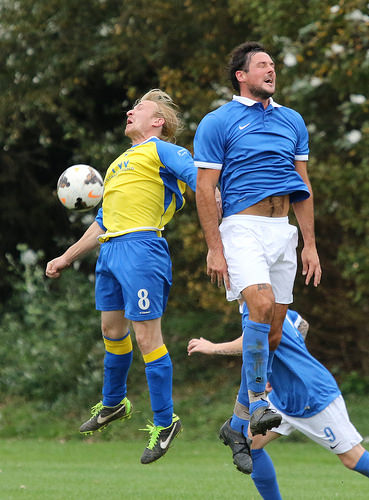<image>
Can you confirm if the man is to the left of the ball? No. The man is not to the left of the ball. From this viewpoint, they have a different horizontal relationship. Is the man behind the man? Yes. From this viewpoint, the man is positioned behind the man, with the man partially or fully occluding the man. Is the ball above the bushes? No. The ball is not positioned above the bushes. The vertical arrangement shows a different relationship. 